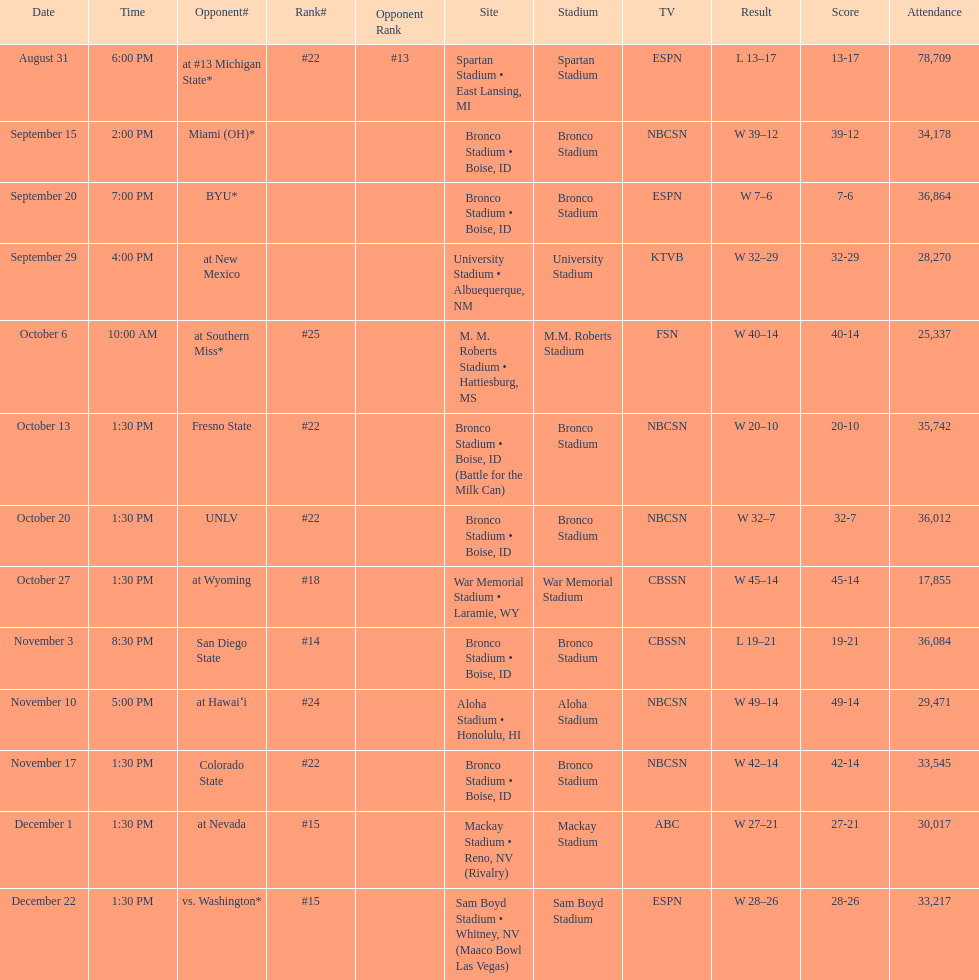Would you be able to parse every entry in this table? {'header': ['Date', 'Time', 'Opponent#', 'Rank#', 'Opponent Rank', 'Site', 'Stadium', 'TV', 'Result', 'Score', 'Attendance'], 'rows': [['August 31', '6:00 PM', 'at\xa0#13\xa0Michigan State*', '#22', '#13', 'Spartan Stadium • East Lansing, MI', 'Spartan Stadium', 'ESPN', 'L\xa013–17', '13-17', '78,709'], ['September 15', '2:00 PM', 'Miami (OH)*', '', '', 'Bronco Stadium • Boise, ID', 'Bronco Stadium', 'NBCSN', 'W\xa039–12', '39-12', '34,178'], ['September 20', '7:00 PM', 'BYU*', '', '', 'Bronco Stadium • Boise, ID', 'Bronco Stadium', 'ESPN', 'W\xa07–6', '7-6', '36,864'], ['September 29', '4:00 PM', 'at\xa0New Mexico', '', '', 'University Stadium • Albuequerque, NM', 'University Stadium', 'KTVB', 'W\xa032–29', '32-29', '28,270'], ['October 6', '10:00 AM', 'at\xa0Southern Miss*', '#25', '', 'M. M. Roberts Stadium • Hattiesburg, MS', 'M.M. Roberts Stadium', 'FSN', 'W\xa040–14', '40-14', '25,337'], ['October 13', '1:30 PM', 'Fresno State', '#22', '', 'Bronco Stadium • Boise, ID (Battle for the Milk Can)', 'Bronco Stadium', 'NBCSN', 'W\xa020–10', '20-10', '35,742'], ['October 20', '1:30 PM', 'UNLV', '#22', '', 'Bronco Stadium • Boise, ID', 'Bronco Stadium', 'NBCSN', 'W\xa032–7', '32-7', '36,012'], ['October 27', '1:30 PM', 'at\xa0Wyoming', '#18', '', 'War Memorial Stadium • Laramie, WY', 'War Memorial Stadium', 'CBSSN', 'W\xa045–14', '45-14', '17,855'], ['November 3', '8:30 PM', 'San Diego State', '#14', '', 'Bronco Stadium • Boise, ID', 'Bronco Stadium', 'CBSSN', 'L\xa019–21', '19-21', '36,084'], ['November 10', '5:00 PM', 'at\xa0Hawaiʻi', '#24', '', 'Aloha Stadium • Honolulu, HI', 'Aloha Stadium', 'NBCSN', 'W\xa049–14', '49-14', '29,471'], ['November 17', '1:30 PM', 'Colorado State', '#22', '', 'Bronco Stadium • Boise, ID', 'Bronco Stadium', 'NBCSN', 'W\xa042–14', '42-14', '33,545'], ['December 1', '1:30 PM', 'at\xa0Nevada', '#15', '', 'Mackay Stadium • Reno, NV (Rivalry)', 'Mackay Stadium', 'ABC', 'W\xa027–21', '27-21', '30,017'], ['December 22', '1:30 PM', 'vs.\xa0Washington*', '#15', '', 'Sam Boyd Stadium • Whitney, NV (Maaco Bowl Las Vegas)', 'Sam Boyd Stadium', 'ESPN', 'W\xa028–26', '28-26', '33,217']]} What was their peak ranking during the season? #14. 